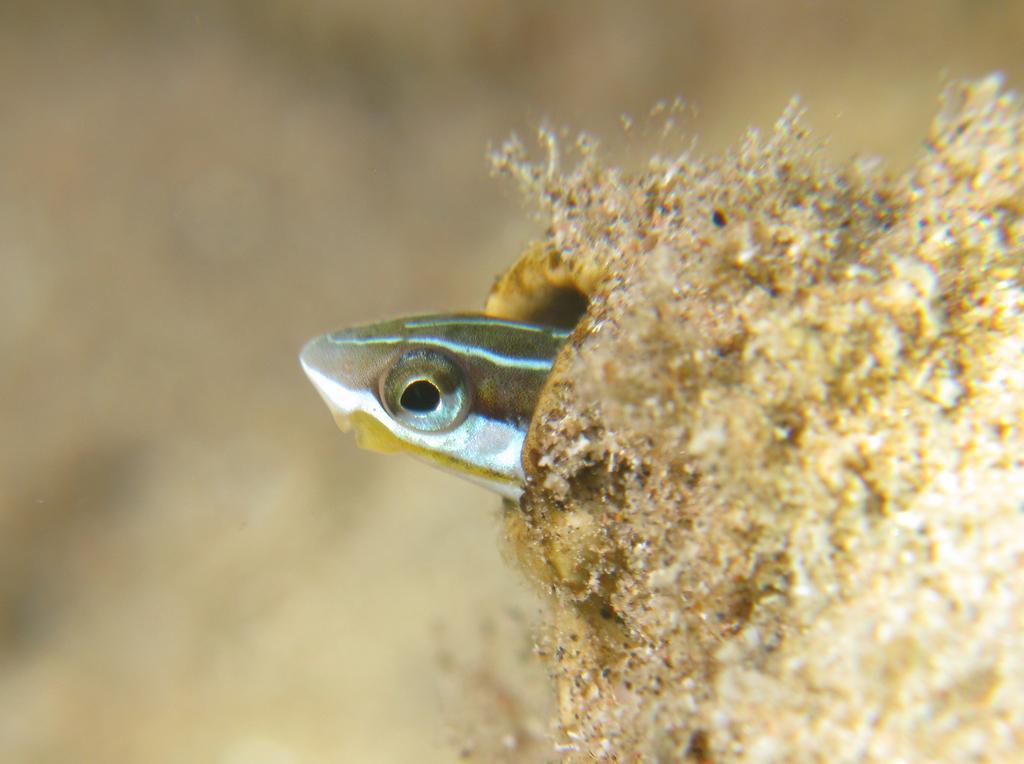Please provide a concise description of this image. In the picture we can see an amphibian looking out from the hole with a eye. 